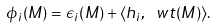<formula> <loc_0><loc_0><loc_500><loc_500>\phi _ { i } ( M ) = \epsilon _ { i } ( M ) + \langle h _ { i } , \ w t ( M ) \rangle .</formula> 